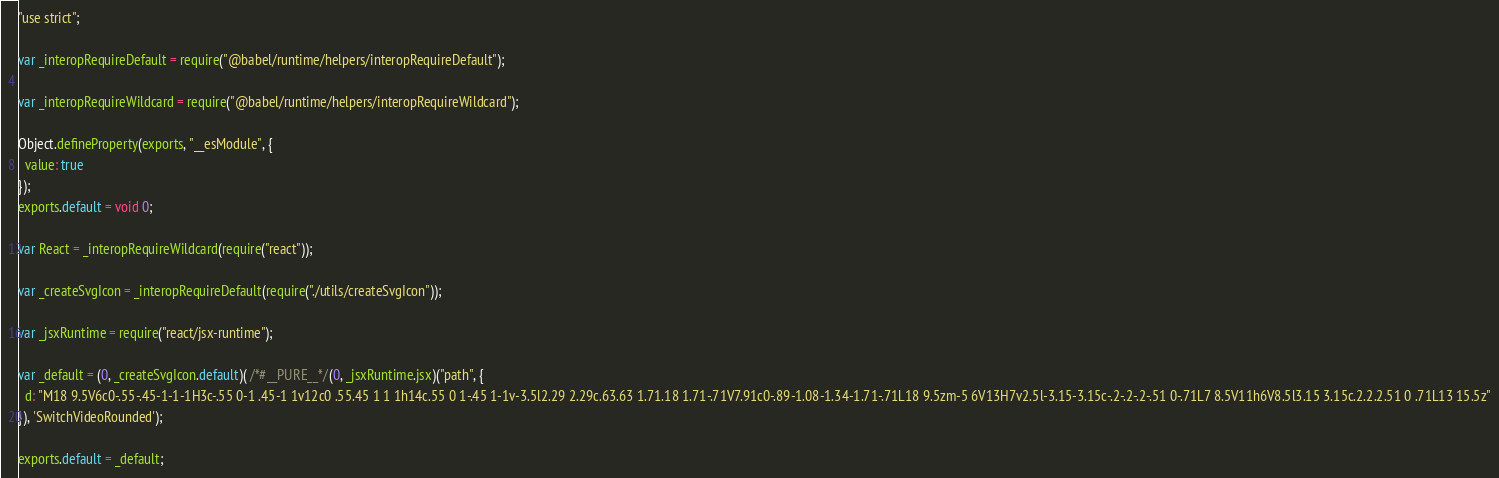Convert code to text. <code><loc_0><loc_0><loc_500><loc_500><_JavaScript_>"use strict";

var _interopRequireDefault = require("@babel/runtime/helpers/interopRequireDefault");

var _interopRequireWildcard = require("@babel/runtime/helpers/interopRequireWildcard");

Object.defineProperty(exports, "__esModule", {
  value: true
});
exports.default = void 0;

var React = _interopRequireWildcard(require("react"));

var _createSvgIcon = _interopRequireDefault(require("./utils/createSvgIcon"));

var _jsxRuntime = require("react/jsx-runtime");

var _default = (0, _createSvgIcon.default)( /*#__PURE__*/(0, _jsxRuntime.jsx)("path", {
  d: "M18 9.5V6c0-.55-.45-1-1-1H3c-.55 0-1 .45-1 1v12c0 .55.45 1 1 1h14c.55 0 1-.45 1-1v-3.5l2.29 2.29c.63.63 1.71.18 1.71-.71V7.91c0-.89-1.08-1.34-1.71-.71L18 9.5zm-5 6V13H7v2.5l-3.15-3.15c-.2-.2-.2-.51 0-.71L7 8.5V11h6V8.5l3.15 3.15c.2.2.2.51 0 .71L13 15.5z"
}), 'SwitchVideoRounded');

exports.default = _default;</code> 